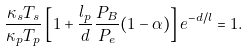<formula> <loc_0><loc_0><loc_500><loc_500>\frac { \kappa _ { s } T _ { s } } { \kappa _ { p } T _ { p } } \left [ 1 + \frac { l _ { p } } { d } \frac { P _ { B } } { P _ { e } } ( 1 - \alpha ) \right ] e ^ { - d / l } = 1 .</formula> 